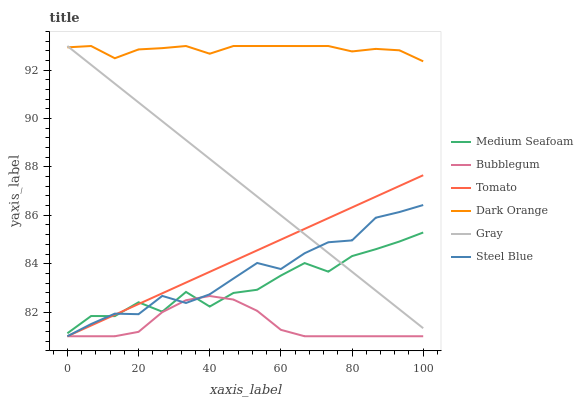Does Gray have the minimum area under the curve?
Answer yes or no. No. Does Gray have the maximum area under the curve?
Answer yes or no. No. Is Dark Orange the smoothest?
Answer yes or no. No. Is Dark Orange the roughest?
Answer yes or no. No. Does Gray have the lowest value?
Answer yes or no. No. Does Steel Blue have the highest value?
Answer yes or no. No. Is Bubblegum less than Gray?
Answer yes or no. Yes. Is Dark Orange greater than Medium Seafoam?
Answer yes or no. Yes. Does Bubblegum intersect Gray?
Answer yes or no. No. 